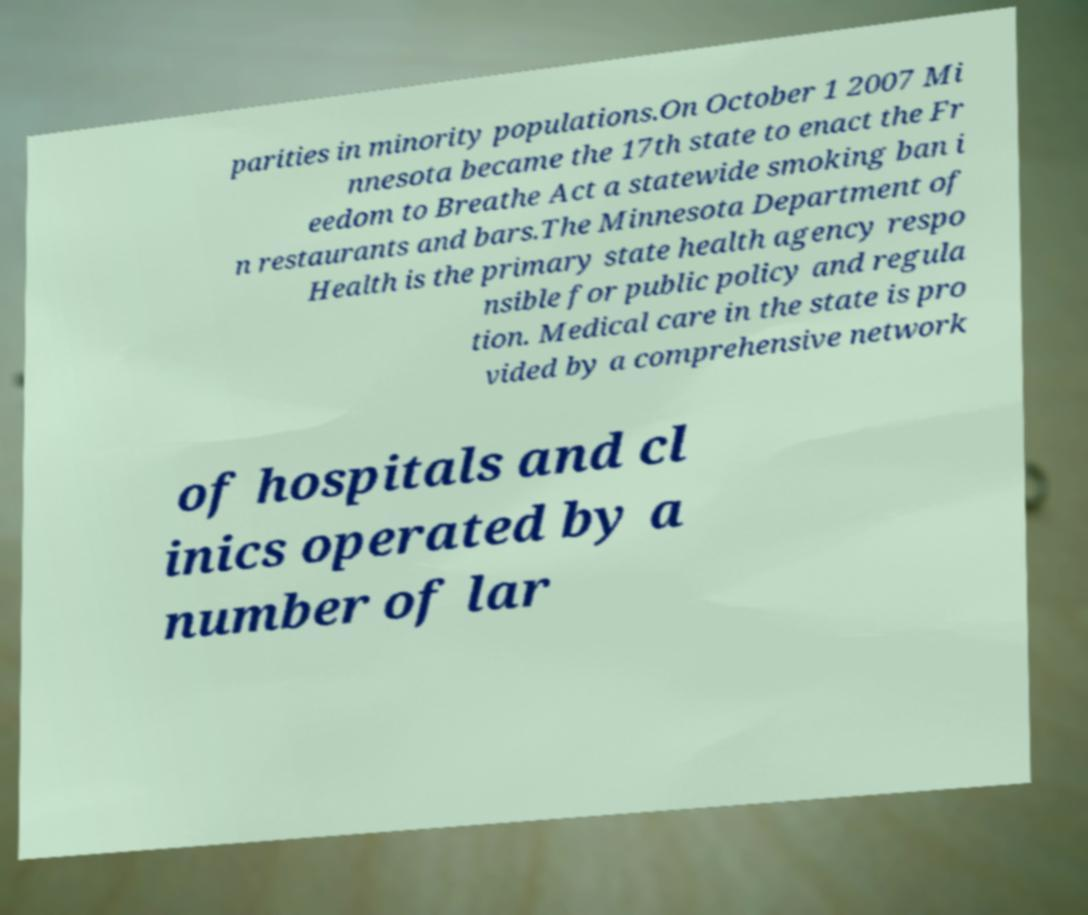Can you read and provide the text displayed in the image?This photo seems to have some interesting text. Can you extract and type it out for me? parities in minority populations.On October 1 2007 Mi nnesota became the 17th state to enact the Fr eedom to Breathe Act a statewide smoking ban i n restaurants and bars.The Minnesota Department of Health is the primary state health agency respo nsible for public policy and regula tion. Medical care in the state is pro vided by a comprehensive network of hospitals and cl inics operated by a number of lar 